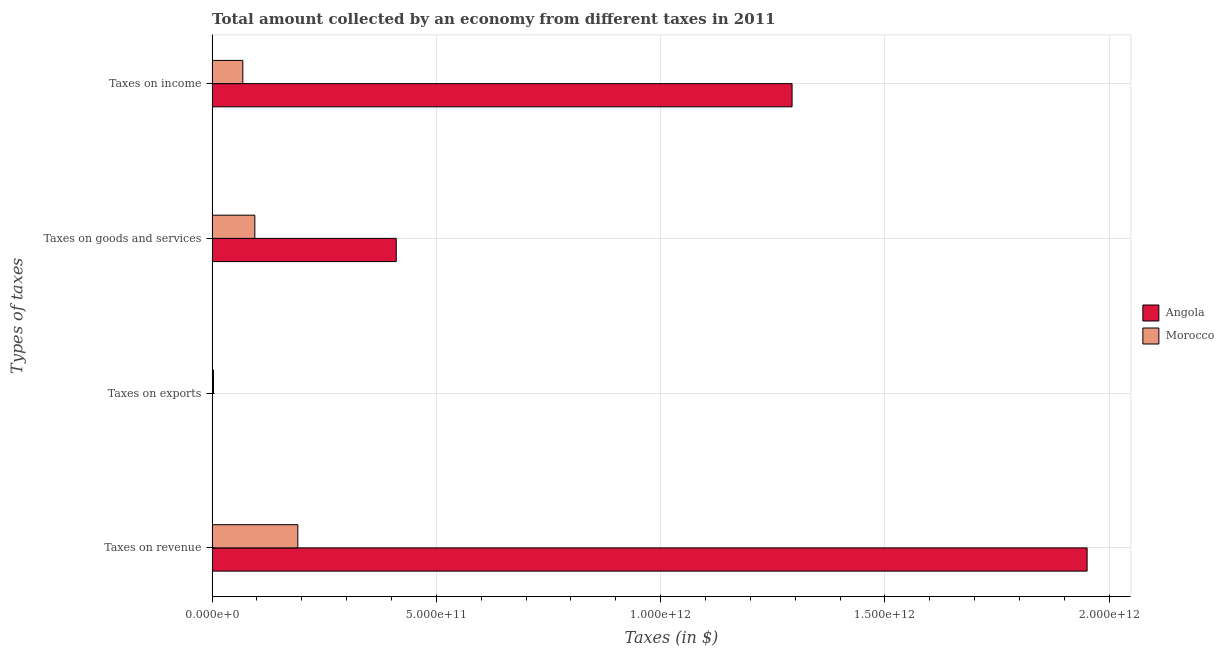How many groups of bars are there?
Keep it short and to the point. 4. Are the number of bars per tick equal to the number of legend labels?
Offer a terse response. Yes. Are the number of bars on each tick of the Y-axis equal?
Ensure brevity in your answer.  Yes. How many bars are there on the 2nd tick from the top?
Your response must be concise. 2. How many bars are there on the 1st tick from the bottom?
Make the answer very short. 2. What is the label of the 1st group of bars from the top?
Ensure brevity in your answer.  Taxes on income. What is the amount collected as tax on goods in Morocco?
Give a very brief answer. 9.52e+1. Across all countries, what is the maximum amount collected as tax on income?
Your answer should be very brief. 1.29e+12. Across all countries, what is the minimum amount collected as tax on revenue?
Provide a succinct answer. 1.91e+11. In which country was the amount collected as tax on goods maximum?
Offer a very short reply. Angola. In which country was the amount collected as tax on income minimum?
Provide a succinct answer. Morocco. What is the total amount collected as tax on revenue in the graph?
Offer a terse response. 2.14e+12. What is the difference between the amount collected as tax on income in Morocco and that in Angola?
Make the answer very short. -1.22e+12. What is the difference between the amount collected as tax on revenue in Morocco and the amount collected as tax on goods in Angola?
Offer a very short reply. -2.19e+11. What is the average amount collected as tax on income per country?
Ensure brevity in your answer.  6.81e+11. What is the difference between the amount collected as tax on revenue and amount collected as tax on income in Morocco?
Offer a terse response. 1.23e+11. In how many countries, is the amount collected as tax on exports greater than 1000000000000 $?
Make the answer very short. 0. What is the ratio of the amount collected as tax on revenue in Morocco to that in Angola?
Your answer should be compact. 0.1. What is the difference between the highest and the second highest amount collected as tax on goods?
Provide a succinct answer. 3.15e+11. What is the difference between the highest and the lowest amount collected as tax on revenue?
Your answer should be compact. 1.76e+12. In how many countries, is the amount collected as tax on exports greater than the average amount collected as tax on exports taken over all countries?
Keep it short and to the point. 1. What does the 2nd bar from the top in Taxes on goods and services represents?
Offer a terse response. Angola. What does the 1st bar from the bottom in Taxes on goods and services represents?
Your answer should be compact. Angola. How many countries are there in the graph?
Make the answer very short. 2. What is the difference between two consecutive major ticks on the X-axis?
Your response must be concise. 5.00e+11. Are the values on the major ticks of X-axis written in scientific E-notation?
Ensure brevity in your answer.  Yes. Does the graph contain grids?
Keep it short and to the point. Yes. Where does the legend appear in the graph?
Keep it short and to the point. Center right. How are the legend labels stacked?
Provide a short and direct response. Vertical. What is the title of the graph?
Your response must be concise. Total amount collected by an economy from different taxes in 2011. What is the label or title of the X-axis?
Give a very brief answer. Taxes (in $). What is the label or title of the Y-axis?
Give a very brief answer. Types of taxes. What is the Taxes (in $) in Angola in Taxes on revenue?
Your answer should be compact. 1.95e+12. What is the Taxes (in $) of Morocco in Taxes on revenue?
Your response must be concise. 1.91e+11. What is the Taxes (in $) of Angola in Taxes on exports?
Keep it short and to the point. 1.11e+07. What is the Taxes (in $) in Morocco in Taxes on exports?
Offer a very short reply. 3.00e+09. What is the Taxes (in $) of Angola in Taxes on goods and services?
Make the answer very short. 4.10e+11. What is the Taxes (in $) of Morocco in Taxes on goods and services?
Your answer should be very brief. 9.52e+1. What is the Taxes (in $) of Angola in Taxes on income?
Keep it short and to the point. 1.29e+12. What is the Taxes (in $) of Morocco in Taxes on income?
Keep it short and to the point. 6.85e+1. Across all Types of taxes, what is the maximum Taxes (in $) of Angola?
Your answer should be very brief. 1.95e+12. Across all Types of taxes, what is the maximum Taxes (in $) of Morocco?
Provide a short and direct response. 1.91e+11. Across all Types of taxes, what is the minimum Taxes (in $) of Angola?
Keep it short and to the point. 1.11e+07. Across all Types of taxes, what is the minimum Taxes (in $) in Morocco?
Offer a very short reply. 3.00e+09. What is the total Taxes (in $) of Angola in the graph?
Ensure brevity in your answer.  3.65e+12. What is the total Taxes (in $) in Morocco in the graph?
Offer a terse response. 3.58e+11. What is the difference between the Taxes (in $) in Angola in Taxes on revenue and that in Taxes on exports?
Ensure brevity in your answer.  1.95e+12. What is the difference between the Taxes (in $) of Morocco in Taxes on revenue and that in Taxes on exports?
Give a very brief answer. 1.88e+11. What is the difference between the Taxes (in $) in Angola in Taxes on revenue and that in Taxes on goods and services?
Give a very brief answer. 1.54e+12. What is the difference between the Taxes (in $) in Morocco in Taxes on revenue and that in Taxes on goods and services?
Ensure brevity in your answer.  9.58e+1. What is the difference between the Taxes (in $) in Angola in Taxes on revenue and that in Taxes on income?
Your answer should be compact. 6.58e+11. What is the difference between the Taxes (in $) of Morocco in Taxes on revenue and that in Taxes on income?
Offer a very short reply. 1.23e+11. What is the difference between the Taxes (in $) of Angola in Taxes on exports and that in Taxes on goods and services?
Your response must be concise. -4.10e+11. What is the difference between the Taxes (in $) in Morocco in Taxes on exports and that in Taxes on goods and services?
Ensure brevity in your answer.  -9.22e+1. What is the difference between the Taxes (in $) in Angola in Taxes on exports and that in Taxes on income?
Your answer should be compact. -1.29e+12. What is the difference between the Taxes (in $) in Morocco in Taxes on exports and that in Taxes on income?
Ensure brevity in your answer.  -6.55e+1. What is the difference between the Taxes (in $) in Angola in Taxes on goods and services and that in Taxes on income?
Keep it short and to the point. -8.82e+11. What is the difference between the Taxes (in $) of Morocco in Taxes on goods and services and that in Taxes on income?
Make the answer very short. 2.68e+1. What is the difference between the Taxes (in $) of Angola in Taxes on revenue and the Taxes (in $) of Morocco in Taxes on exports?
Offer a terse response. 1.95e+12. What is the difference between the Taxes (in $) of Angola in Taxes on revenue and the Taxes (in $) of Morocco in Taxes on goods and services?
Ensure brevity in your answer.  1.86e+12. What is the difference between the Taxes (in $) in Angola in Taxes on revenue and the Taxes (in $) in Morocco in Taxes on income?
Your answer should be very brief. 1.88e+12. What is the difference between the Taxes (in $) of Angola in Taxes on exports and the Taxes (in $) of Morocco in Taxes on goods and services?
Give a very brief answer. -9.52e+1. What is the difference between the Taxes (in $) of Angola in Taxes on exports and the Taxes (in $) of Morocco in Taxes on income?
Your answer should be very brief. -6.84e+1. What is the difference between the Taxes (in $) of Angola in Taxes on goods and services and the Taxes (in $) of Morocco in Taxes on income?
Provide a short and direct response. 3.42e+11. What is the average Taxes (in $) of Angola per Types of taxes?
Your response must be concise. 9.13e+11. What is the average Taxes (in $) in Morocco per Types of taxes?
Offer a very short reply. 8.94e+1. What is the difference between the Taxes (in $) in Angola and Taxes (in $) in Morocco in Taxes on revenue?
Give a very brief answer. 1.76e+12. What is the difference between the Taxes (in $) in Angola and Taxes (in $) in Morocco in Taxes on exports?
Give a very brief answer. -2.99e+09. What is the difference between the Taxes (in $) in Angola and Taxes (in $) in Morocco in Taxes on goods and services?
Your response must be concise. 3.15e+11. What is the difference between the Taxes (in $) of Angola and Taxes (in $) of Morocco in Taxes on income?
Give a very brief answer. 1.22e+12. What is the ratio of the Taxes (in $) of Angola in Taxes on revenue to that in Taxes on exports?
Your answer should be compact. 1.75e+05. What is the ratio of the Taxes (in $) in Morocco in Taxes on revenue to that in Taxes on exports?
Provide a short and direct response. 63.68. What is the ratio of the Taxes (in $) of Angola in Taxes on revenue to that in Taxes on goods and services?
Your response must be concise. 4.75. What is the ratio of the Taxes (in $) in Morocco in Taxes on revenue to that in Taxes on goods and services?
Provide a short and direct response. 2.01. What is the ratio of the Taxes (in $) in Angola in Taxes on revenue to that in Taxes on income?
Provide a short and direct response. 1.51. What is the ratio of the Taxes (in $) of Morocco in Taxes on revenue to that in Taxes on income?
Offer a very short reply. 2.79. What is the ratio of the Taxes (in $) in Angola in Taxes on exports to that in Taxes on goods and services?
Offer a very short reply. 0. What is the ratio of the Taxes (in $) in Morocco in Taxes on exports to that in Taxes on goods and services?
Your answer should be very brief. 0.03. What is the ratio of the Taxes (in $) of Angola in Taxes on exports to that in Taxes on income?
Provide a short and direct response. 0. What is the ratio of the Taxes (in $) in Morocco in Taxes on exports to that in Taxes on income?
Ensure brevity in your answer.  0.04. What is the ratio of the Taxes (in $) of Angola in Taxes on goods and services to that in Taxes on income?
Give a very brief answer. 0.32. What is the ratio of the Taxes (in $) of Morocco in Taxes on goods and services to that in Taxes on income?
Make the answer very short. 1.39. What is the difference between the highest and the second highest Taxes (in $) in Angola?
Keep it short and to the point. 6.58e+11. What is the difference between the highest and the second highest Taxes (in $) in Morocco?
Give a very brief answer. 9.58e+1. What is the difference between the highest and the lowest Taxes (in $) in Angola?
Ensure brevity in your answer.  1.95e+12. What is the difference between the highest and the lowest Taxes (in $) of Morocco?
Make the answer very short. 1.88e+11. 